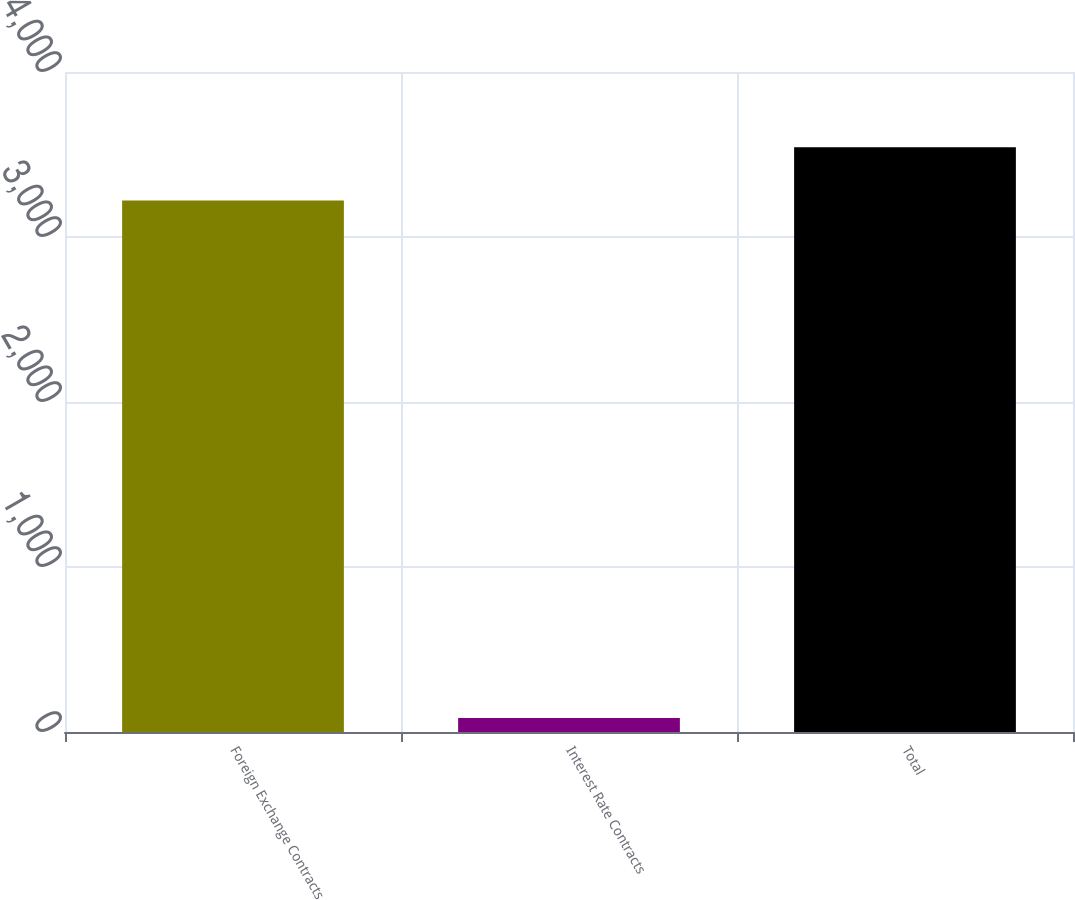Convert chart. <chart><loc_0><loc_0><loc_500><loc_500><bar_chart><fcel>Foreign Exchange Contracts<fcel>Interest Rate Contracts<fcel>Total<nl><fcel>3221.7<fcel>85.2<fcel>3543.87<nl></chart> 